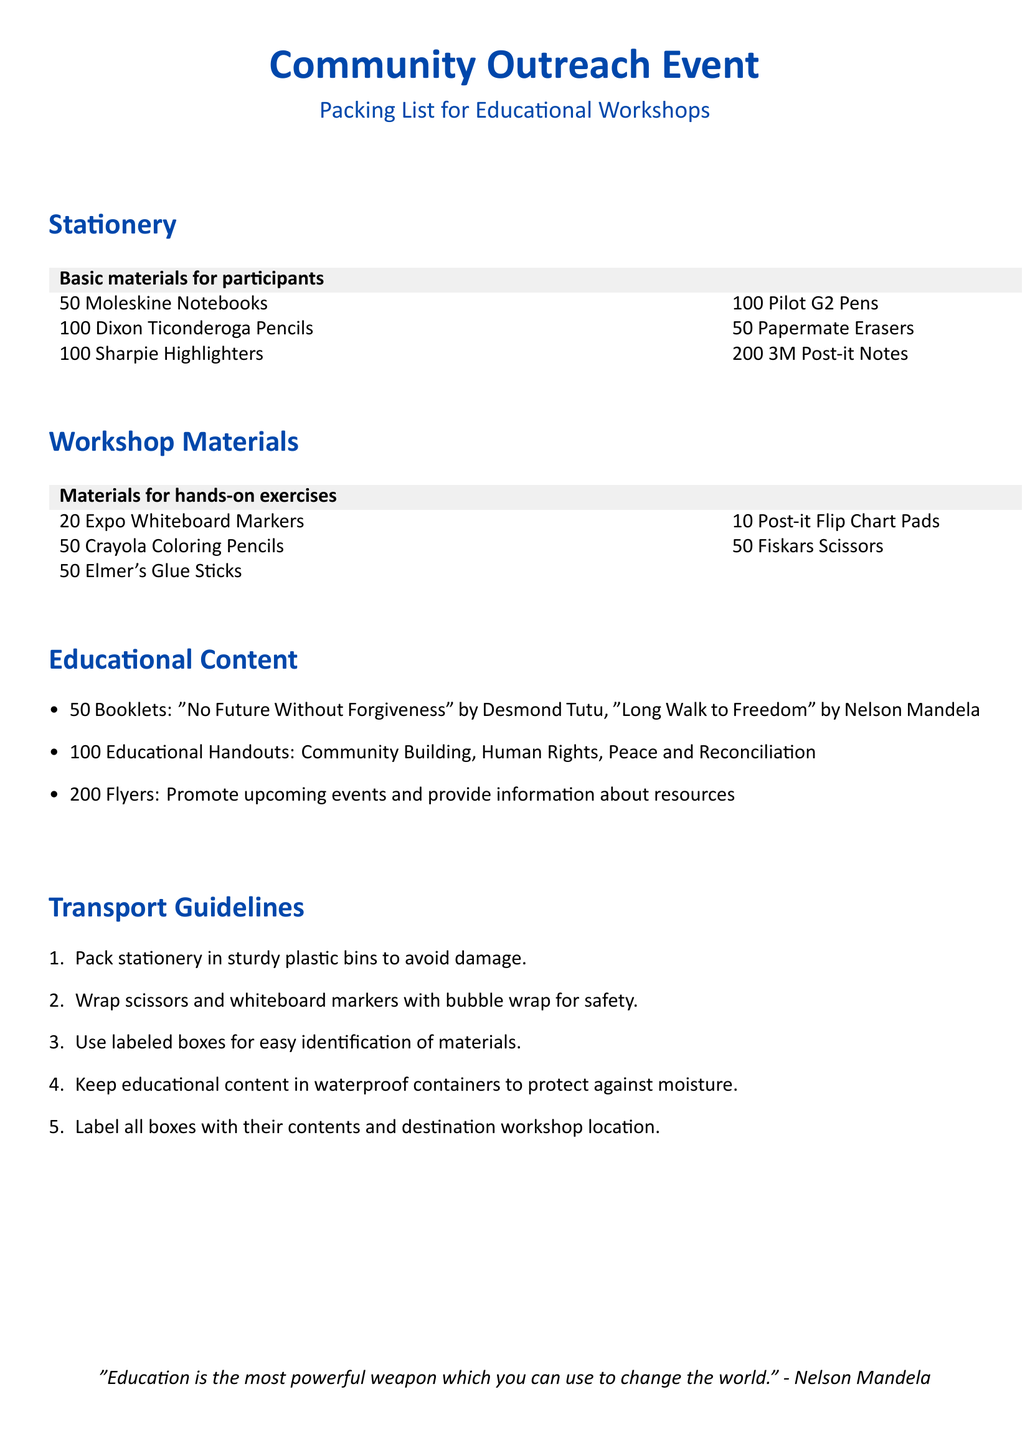What is the total number of Moleskine Notebooks? The document states there are 50 Moleskine Notebooks listed in the stationery section.
Answer: 50 How many different types of pens are included in the packing list? The packing list includes one type of pen, which is the Pilot G2 Pens, and there are 100 counts mentioned.
Answer: 1 What is the name of one educational booklet included in the materials? The packing list mentions "No Future Without Forgiveness" by Desmond Tutu as one of the booklets in the educational content section.
Answer: No Future Without Forgiveness What is the total count of flyers to be distributed? The document states that there are 200 flyers mentioned under educational content for promoting events and providing information.
Answer: 200 What should be used to wrap scissors for transport safety? According to the transport guidelines, scissors should be wrapped with bubble wrap for safety during transportation.
Answer: Bubble wrap What minimum number of Flip Chart Pads is packed for the workshops? The packing list includes 10 Post-it Flip Chart Pads as materials for hands-on exercises.
Answer: 10 Which material should be kept in waterproof containers? The transport guidelines specify that educational content should be kept in waterproof containers to protect against moisture.
Answer: Educational content How many types of scissors are listed in the workshop materials? The packing list specifies only one type of scissors which is Fiskars Scissors, with a count of 50 included.
Answer: 1 